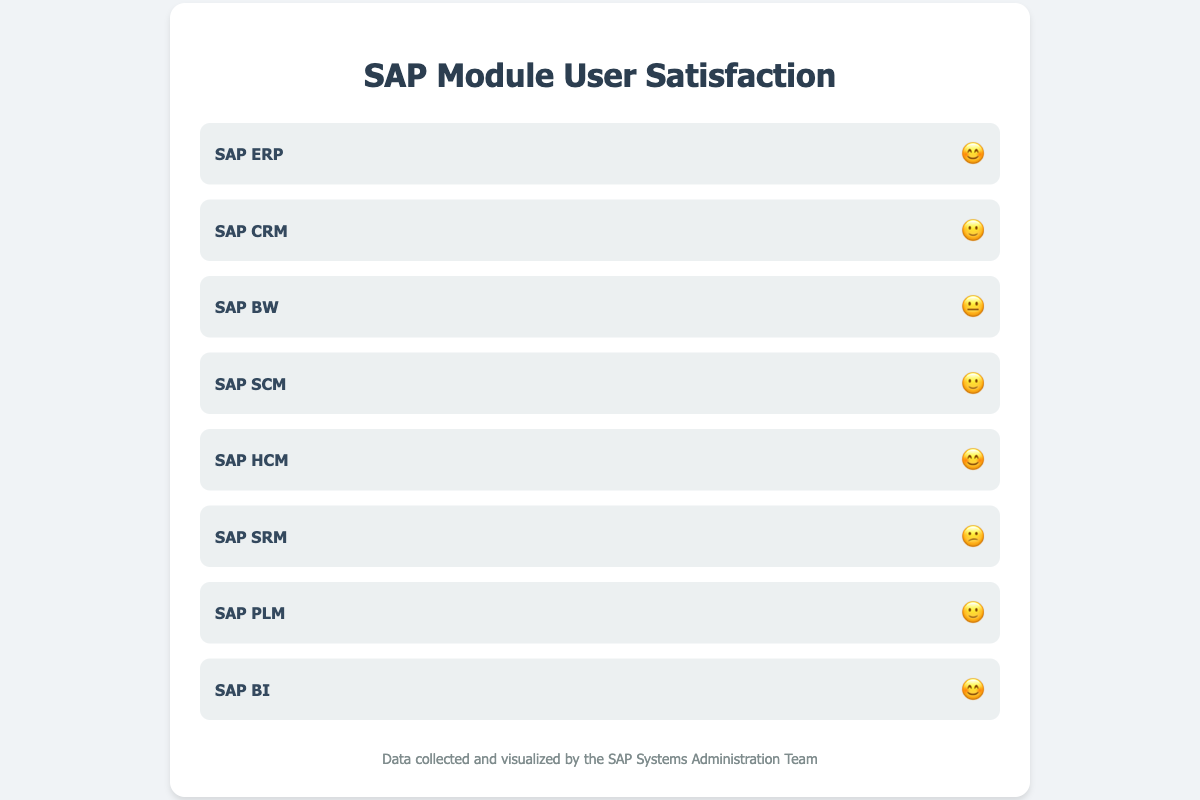Which SAP modules have the highest user satisfaction? The chart shows three SAP modules (ERP, HCM, and BI) with a smiley face emoji (😊), indicating the highest level of user satisfaction.
Answer: SAP ERP, SAP HCM, SAP BI Which SAP module has the lowest user satisfaction? SAP SRM is represented by a slightly frowning face emoji (😕), indicating the lowest user satisfaction compared to the other modules.
Answer: SAP SRM How many SAP modules have a neutral satisfaction rating? The neutral emoji (😐) is displayed next to only one module, indicating that only SAP BW has a neutral satisfaction rating.
Answer: One Compare the user satisfaction between SAP ERP and SAP SRM. SAP ERP has a smiley face emoji (😊), indicating high user satisfaction, while SAP SRM has a slightly frowning emoji (😕), indicating lower user satisfaction.
Answer: SAP ERP has higher satisfaction than SAP SRM Which modules share the same satisfaction rating (represented by emoji)? SAP CRM, SAP SCM, and SAP PLM all share the same emoji face (🙂), indicating similar satisfaction ratings.
Answer: SAP CRM, SAP SCM, SAP PLM How does the user satisfaction of SAP ERP compare with SAP PLM? SAP ERP has a smiley face emoji (😊), indicating high satisfaction, whereas SAP PLM has a slightly smiling face emoji (🙂), indicating moderate satisfaction.
Answer: SAP ERP has higher satisfaction than SAP PLM What is the average number of modules per satisfaction level? There are 8 modules and 4 satisfaction levels (😊,🙂,😐,😕), so the average number of modules per satisfaction level is 8/4 = 2.0
Answer: 2.0 How many modules are perceived as positive (😊 or 🙂)? There is a total of 3 modules with a smiley face emoji (😊) and 3 with a slightly smiling face emoji (🙂), making it 3 + 3 = 6 modules perceived with positive satisfaction.
Answer: Six 